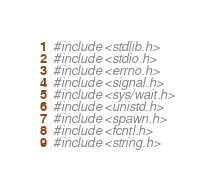<code> <loc_0><loc_0><loc_500><loc_500><_C_>#include <stdlib.h>
#include <stdio.h>
#include <errno.h>
#include <signal.h>
#include <sys/wait.h>
#include <unistd.h>
#include <spawn.h>
#include <fcntl.h>
#include <string.h>

</code> 